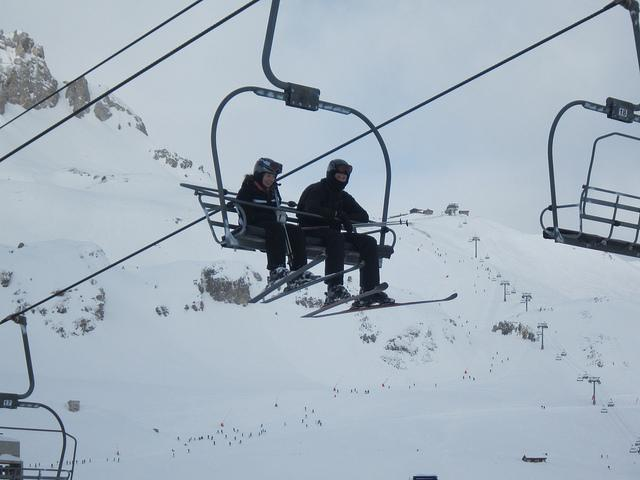The ski lift saves the skiers from a lot of what physical activity? Please explain your reasoning. walking. The lift prevents walking. 